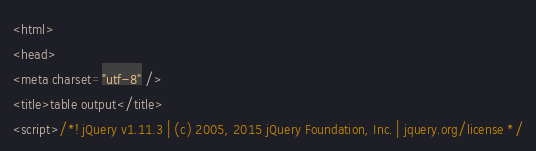Convert code to text. <code><loc_0><loc_0><loc_500><loc_500><_HTML_><html>
<head>
<meta charset="utf-8" />
<title>table output</title>
<script>/*! jQuery v1.11.3 | (c) 2005, 2015 jQuery Foundation, Inc. | jquery.org/license */</code> 